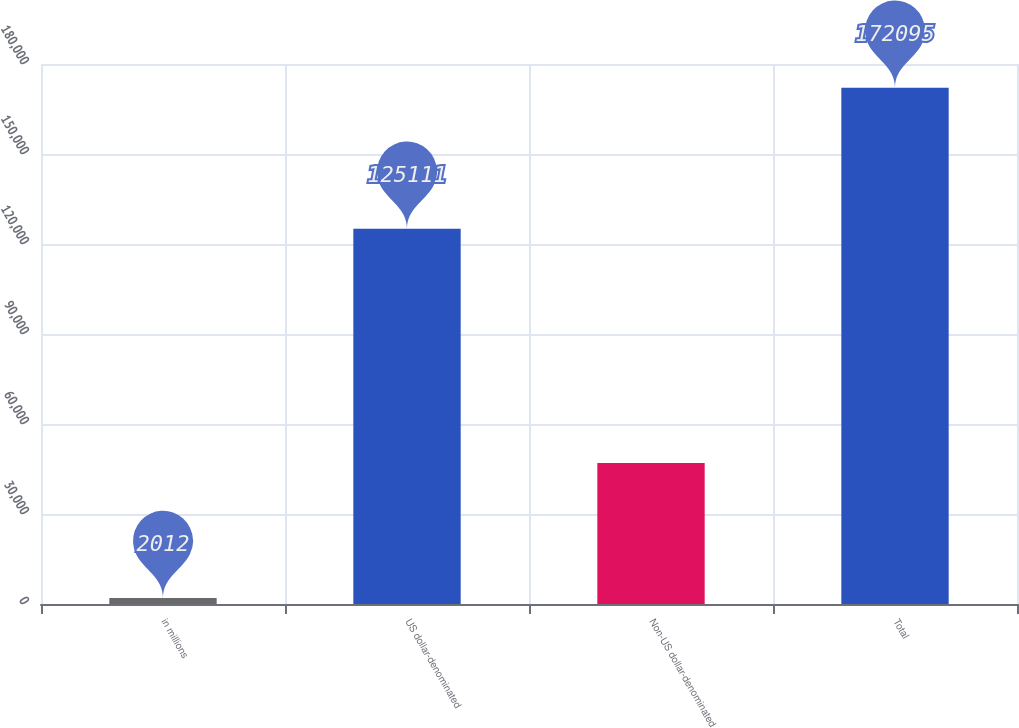<chart> <loc_0><loc_0><loc_500><loc_500><bar_chart><fcel>in millions<fcel>US dollar-denominated<fcel>Non-US dollar-denominated<fcel>Total<nl><fcel>2012<fcel>125111<fcel>46984<fcel>172095<nl></chart> 